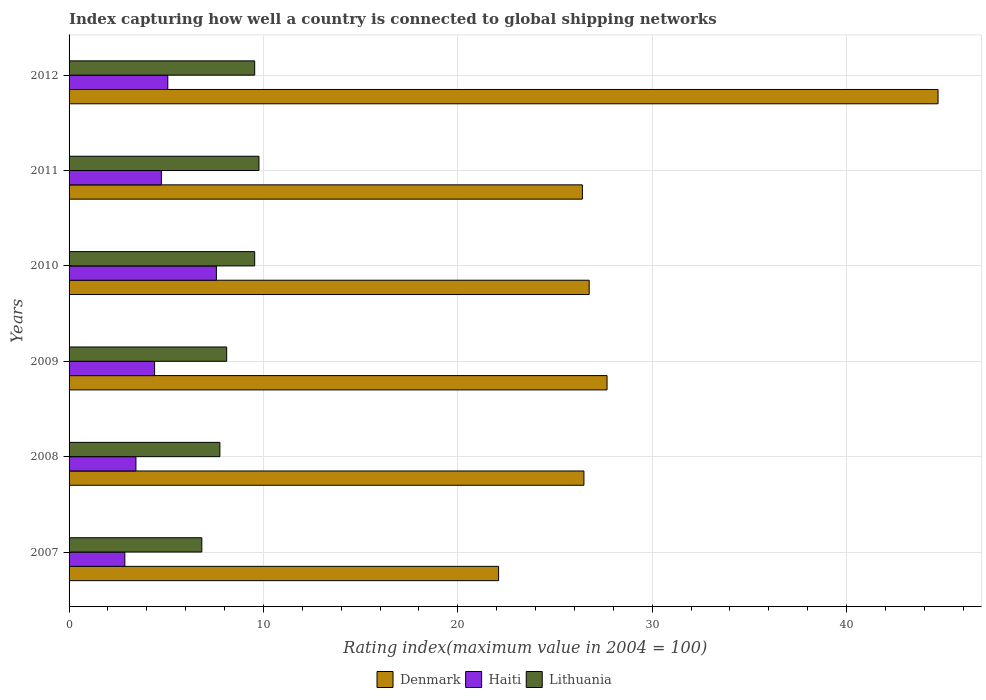How many bars are there on the 3rd tick from the top?
Provide a succinct answer. 3. How many bars are there on the 6th tick from the bottom?
Your answer should be very brief. 3. What is the label of the 6th group of bars from the top?
Your answer should be very brief. 2007. What is the rating index in Lithuania in 2007?
Your response must be concise. 6.83. Across all years, what is the maximum rating index in Haiti?
Your answer should be very brief. 7.58. Across all years, what is the minimum rating index in Lithuania?
Your answer should be very brief. 6.83. In which year was the rating index in Denmark maximum?
Ensure brevity in your answer.  2012. What is the total rating index in Denmark in the graph?
Provide a succinct answer. 174.15. What is the difference between the rating index in Lithuania in 2009 and that in 2012?
Keep it short and to the point. -1.44. What is the difference between the rating index in Haiti in 2010 and the rating index in Denmark in 2008?
Give a very brief answer. -18.91. What is the average rating index in Lithuania per year?
Your answer should be very brief. 8.59. In the year 2008, what is the difference between the rating index in Haiti and rating index in Denmark?
Give a very brief answer. -23.05. In how many years, is the rating index in Denmark greater than 38 ?
Provide a short and direct response. 1. What is the ratio of the rating index in Denmark in 2007 to that in 2009?
Your answer should be very brief. 0.8. Is the difference between the rating index in Haiti in 2009 and 2012 greater than the difference between the rating index in Denmark in 2009 and 2012?
Offer a terse response. Yes. What is the difference between the highest and the second highest rating index in Denmark?
Your answer should be compact. 17.03. What is the difference between the highest and the lowest rating index in Denmark?
Provide a succinct answer. 22.61. What does the 3rd bar from the top in 2009 represents?
Provide a short and direct response. Denmark. What does the 1st bar from the bottom in 2012 represents?
Your response must be concise. Denmark. Are all the bars in the graph horizontal?
Provide a succinct answer. Yes. Are the values on the major ticks of X-axis written in scientific E-notation?
Give a very brief answer. No. Does the graph contain any zero values?
Offer a terse response. No. Does the graph contain grids?
Provide a short and direct response. Yes. Where does the legend appear in the graph?
Your answer should be very brief. Bottom center. How are the legend labels stacked?
Your answer should be compact. Horizontal. What is the title of the graph?
Your answer should be compact. Index capturing how well a country is connected to global shipping networks. What is the label or title of the X-axis?
Keep it short and to the point. Rating index(maximum value in 2004 = 100). What is the Rating index(maximum value in 2004 = 100) in Denmark in 2007?
Your answer should be very brief. 22.1. What is the Rating index(maximum value in 2004 = 100) of Haiti in 2007?
Provide a succinct answer. 2.87. What is the Rating index(maximum value in 2004 = 100) in Lithuania in 2007?
Offer a very short reply. 6.83. What is the Rating index(maximum value in 2004 = 100) in Denmark in 2008?
Your response must be concise. 26.49. What is the Rating index(maximum value in 2004 = 100) in Haiti in 2008?
Keep it short and to the point. 3.44. What is the Rating index(maximum value in 2004 = 100) of Lithuania in 2008?
Provide a short and direct response. 7.76. What is the Rating index(maximum value in 2004 = 100) in Denmark in 2009?
Give a very brief answer. 27.68. What is the Rating index(maximum value in 2004 = 100) of Haiti in 2009?
Offer a terse response. 4.4. What is the Rating index(maximum value in 2004 = 100) of Lithuania in 2009?
Provide a short and direct response. 8.11. What is the Rating index(maximum value in 2004 = 100) of Denmark in 2010?
Your answer should be very brief. 26.76. What is the Rating index(maximum value in 2004 = 100) of Haiti in 2010?
Provide a short and direct response. 7.58. What is the Rating index(maximum value in 2004 = 100) of Lithuania in 2010?
Keep it short and to the point. 9.55. What is the Rating index(maximum value in 2004 = 100) of Denmark in 2011?
Make the answer very short. 26.41. What is the Rating index(maximum value in 2004 = 100) in Haiti in 2011?
Offer a very short reply. 4.75. What is the Rating index(maximum value in 2004 = 100) in Lithuania in 2011?
Keep it short and to the point. 9.77. What is the Rating index(maximum value in 2004 = 100) in Denmark in 2012?
Offer a very short reply. 44.71. What is the Rating index(maximum value in 2004 = 100) of Haiti in 2012?
Keep it short and to the point. 5.08. What is the Rating index(maximum value in 2004 = 100) of Lithuania in 2012?
Give a very brief answer. 9.55. Across all years, what is the maximum Rating index(maximum value in 2004 = 100) in Denmark?
Keep it short and to the point. 44.71. Across all years, what is the maximum Rating index(maximum value in 2004 = 100) of Haiti?
Make the answer very short. 7.58. Across all years, what is the maximum Rating index(maximum value in 2004 = 100) of Lithuania?
Offer a very short reply. 9.77. Across all years, what is the minimum Rating index(maximum value in 2004 = 100) of Denmark?
Give a very brief answer. 22.1. Across all years, what is the minimum Rating index(maximum value in 2004 = 100) of Haiti?
Ensure brevity in your answer.  2.87. Across all years, what is the minimum Rating index(maximum value in 2004 = 100) of Lithuania?
Keep it short and to the point. 6.83. What is the total Rating index(maximum value in 2004 = 100) in Denmark in the graph?
Make the answer very short. 174.15. What is the total Rating index(maximum value in 2004 = 100) of Haiti in the graph?
Provide a succinct answer. 28.12. What is the total Rating index(maximum value in 2004 = 100) in Lithuania in the graph?
Your answer should be compact. 51.57. What is the difference between the Rating index(maximum value in 2004 = 100) in Denmark in 2007 and that in 2008?
Your answer should be very brief. -4.39. What is the difference between the Rating index(maximum value in 2004 = 100) in Haiti in 2007 and that in 2008?
Provide a short and direct response. -0.57. What is the difference between the Rating index(maximum value in 2004 = 100) of Lithuania in 2007 and that in 2008?
Make the answer very short. -0.93. What is the difference between the Rating index(maximum value in 2004 = 100) of Denmark in 2007 and that in 2009?
Make the answer very short. -5.58. What is the difference between the Rating index(maximum value in 2004 = 100) in Haiti in 2007 and that in 2009?
Your answer should be compact. -1.53. What is the difference between the Rating index(maximum value in 2004 = 100) in Lithuania in 2007 and that in 2009?
Offer a very short reply. -1.28. What is the difference between the Rating index(maximum value in 2004 = 100) in Denmark in 2007 and that in 2010?
Provide a short and direct response. -4.66. What is the difference between the Rating index(maximum value in 2004 = 100) of Haiti in 2007 and that in 2010?
Your answer should be compact. -4.71. What is the difference between the Rating index(maximum value in 2004 = 100) in Lithuania in 2007 and that in 2010?
Offer a very short reply. -2.72. What is the difference between the Rating index(maximum value in 2004 = 100) of Denmark in 2007 and that in 2011?
Make the answer very short. -4.31. What is the difference between the Rating index(maximum value in 2004 = 100) of Haiti in 2007 and that in 2011?
Your answer should be very brief. -1.88. What is the difference between the Rating index(maximum value in 2004 = 100) of Lithuania in 2007 and that in 2011?
Your response must be concise. -2.94. What is the difference between the Rating index(maximum value in 2004 = 100) in Denmark in 2007 and that in 2012?
Offer a terse response. -22.61. What is the difference between the Rating index(maximum value in 2004 = 100) in Haiti in 2007 and that in 2012?
Provide a succinct answer. -2.21. What is the difference between the Rating index(maximum value in 2004 = 100) of Lithuania in 2007 and that in 2012?
Give a very brief answer. -2.72. What is the difference between the Rating index(maximum value in 2004 = 100) in Denmark in 2008 and that in 2009?
Ensure brevity in your answer.  -1.19. What is the difference between the Rating index(maximum value in 2004 = 100) of Haiti in 2008 and that in 2009?
Your answer should be very brief. -0.96. What is the difference between the Rating index(maximum value in 2004 = 100) in Lithuania in 2008 and that in 2009?
Your answer should be compact. -0.35. What is the difference between the Rating index(maximum value in 2004 = 100) of Denmark in 2008 and that in 2010?
Provide a succinct answer. -0.27. What is the difference between the Rating index(maximum value in 2004 = 100) in Haiti in 2008 and that in 2010?
Your answer should be very brief. -4.14. What is the difference between the Rating index(maximum value in 2004 = 100) of Lithuania in 2008 and that in 2010?
Your response must be concise. -1.79. What is the difference between the Rating index(maximum value in 2004 = 100) of Haiti in 2008 and that in 2011?
Offer a very short reply. -1.31. What is the difference between the Rating index(maximum value in 2004 = 100) of Lithuania in 2008 and that in 2011?
Offer a terse response. -2.01. What is the difference between the Rating index(maximum value in 2004 = 100) in Denmark in 2008 and that in 2012?
Your answer should be very brief. -18.22. What is the difference between the Rating index(maximum value in 2004 = 100) in Haiti in 2008 and that in 2012?
Offer a very short reply. -1.64. What is the difference between the Rating index(maximum value in 2004 = 100) of Lithuania in 2008 and that in 2012?
Give a very brief answer. -1.79. What is the difference between the Rating index(maximum value in 2004 = 100) of Haiti in 2009 and that in 2010?
Your response must be concise. -3.18. What is the difference between the Rating index(maximum value in 2004 = 100) in Lithuania in 2009 and that in 2010?
Keep it short and to the point. -1.44. What is the difference between the Rating index(maximum value in 2004 = 100) of Denmark in 2009 and that in 2011?
Provide a succinct answer. 1.27. What is the difference between the Rating index(maximum value in 2004 = 100) of Haiti in 2009 and that in 2011?
Give a very brief answer. -0.35. What is the difference between the Rating index(maximum value in 2004 = 100) of Lithuania in 2009 and that in 2011?
Keep it short and to the point. -1.66. What is the difference between the Rating index(maximum value in 2004 = 100) of Denmark in 2009 and that in 2012?
Provide a succinct answer. -17.03. What is the difference between the Rating index(maximum value in 2004 = 100) in Haiti in 2009 and that in 2012?
Your answer should be compact. -0.68. What is the difference between the Rating index(maximum value in 2004 = 100) of Lithuania in 2009 and that in 2012?
Give a very brief answer. -1.44. What is the difference between the Rating index(maximum value in 2004 = 100) in Haiti in 2010 and that in 2011?
Your answer should be very brief. 2.83. What is the difference between the Rating index(maximum value in 2004 = 100) of Lithuania in 2010 and that in 2011?
Offer a very short reply. -0.22. What is the difference between the Rating index(maximum value in 2004 = 100) in Denmark in 2010 and that in 2012?
Offer a very short reply. -17.95. What is the difference between the Rating index(maximum value in 2004 = 100) of Haiti in 2010 and that in 2012?
Offer a very short reply. 2.5. What is the difference between the Rating index(maximum value in 2004 = 100) of Denmark in 2011 and that in 2012?
Ensure brevity in your answer.  -18.3. What is the difference between the Rating index(maximum value in 2004 = 100) of Haiti in 2011 and that in 2012?
Make the answer very short. -0.33. What is the difference between the Rating index(maximum value in 2004 = 100) in Lithuania in 2011 and that in 2012?
Your answer should be compact. 0.22. What is the difference between the Rating index(maximum value in 2004 = 100) in Denmark in 2007 and the Rating index(maximum value in 2004 = 100) in Haiti in 2008?
Your response must be concise. 18.66. What is the difference between the Rating index(maximum value in 2004 = 100) of Denmark in 2007 and the Rating index(maximum value in 2004 = 100) of Lithuania in 2008?
Give a very brief answer. 14.34. What is the difference between the Rating index(maximum value in 2004 = 100) in Haiti in 2007 and the Rating index(maximum value in 2004 = 100) in Lithuania in 2008?
Keep it short and to the point. -4.89. What is the difference between the Rating index(maximum value in 2004 = 100) in Denmark in 2007 and the Rating index(maximum value in 2004 = 100) in Haiti in 2009?
Provide a succinct answer. 17.7. What is the difference between the Rating index(maximum value in 2004 = 100) of Denmark in 2007 and the Rating index(maximum value in 2004 = 100) of Lithuania in 2009?
Provide a short and direct response. 13.99. What is the difference between the Rating index(maximum value in 2004 = 100) in Haiti in 2007 and the Rating index(maximum value in 2004 = 100) in Lithuania in 2009?
Offer a very short reply. -5.24. What is the difference between the Rating index(maximum value in 2004 = 100) in Denmark in 2007 and the Rating index(maximum value in 2004 = 100) in Haiti in 2010?
Make the answer very short. 14.52. What is the difference between the Rating index(maximum value in 2004 = 100) in Denmark in 2007 and the Rating index(maximum value in 2004 = 100) in Lithuania in 2010?
Your answer should be very brief. 12.55. What is the difference between the Rating index(maximum value in 2004 = 100) of Haiti in 2007 and the Rating index(maximum value in 2004 = 100) of Lithuania in 2010?
Provide a succinct answer. -6.68. What is the difference between the Rating index(maximum value in 2004 = 100) in Denmark in 2007 and the Rating index(maximum value in 2004 = 100) in Haiti in 2011?
Your answer should be very brief. 17.35. What is the difference between the Rating index(maximum value in 2004 = 100) in Denmark in 2007 and the Rating index(maximum value in 2004 = 100) in Lithuania in 2011?
Your answer should be compact. 12.33. What is the difference between the Rating index(maximum value in 2004 = 100) of Denmark in 2007 and the Rating index(maximum value in 2004 = 100) of Haiti in 2012?
Provide a succinct answer. 17.02. What is the difference between the Rating index(maximum value in 2004 = 100) of Denmark in 2007 and the Rating index(maximum value in 2004 = 100) of Lithuania in 2012?
Offer a very short reply. 12.55. What is the difference between the Rating index(maximum value in 2004 = 100) in Haiti in 2007 and the Rating index(maximum value in 2004 = 100) in Lithuania in 2012?
Ensure brevity in your answer.  -6.68. What is the difference between the Rating index(maximum value in 2004 = 100) of Denmark in 2008 and the Rating index(maximum value in 2004 = 100) of Haiti in 2009?
Ensure brevity in your answer.  22.09. What is the difference between the Rating index(maximum value in 2004 = 100) in Denmark in 2008 and the Rating index(maximum value in 2004 = 100) in Lithuania in 2009?
Provide a succinct answer. 18.38. What is the difference between the Rating index(maximum value in 2004 = 100) in Haiti in 2008 and the Rating index(maximum value in 2004 = 100) in Lithuania in 2009?
Keep it short and to the point. -4.67. What is the difference between the Rating index(maximum value in 2004 = 100) in Denmark in 2008 and the Rating index(maximum value in 2004 = 100) in Haiti in 2010?
Your response must be concise. 18.91. What is the difference between the Rating index(maximum value in 2004 = 100) of Denmark in 2008 and the Rating index(maximum value in 2004 = 100) of Lithuania in 2010?
Ensure brevity in your answer.  16.94. What is the difference between the Rating index(maximum value in 2004 = 100) of Haiti in 2008 and the Rating index(maximum value in 2004 = 100) of Lithuania in 2010?
Give a very brief answer. -6.11. What is the difference between the Rating index(maximum value in 2004 = 100) of Denmark in 2008 and the Rating index(maximum value in 2004 = 100) of Haiti in 2011?
Give a very brief answer. 21.74. What is the difference between the Rating index(maximum value in 2004 = 100) of Denmark in 2008 and the Rating index(maximum value in 2004 = 100) of Lithuania in 2011?
Keep it short and to the point. 16.72. What is the difference between the Rating index(maximum value in 2004 = 100) in Haiti in 2008 and the Rating index(maximum value in 2004 = 100) in Lithuania in 2011?
Ensure brevity in your answer.  -6.33. What is the difference between the Rating index(maximum value in 2004 = 100) of Denmark in 2008 and the Rating index(maximum value in 2004 = 100) of Haiti in 2012?
Provide a succinct answer. 21.41. What is the difference between the Rating index(maximum value in 2004 = 100) of Denmark in 2008 and the Rating index(maximum value in 2004 = 100) of Lithuania in 2012?
Ensure brevity in your answer.  16.94. What is the difference between the Rating index(maximum value in 2004 = 100) in Haiti in 2008 and the Rating index(maximum value in 2004 = 100) in Lithuania in 2012?
Offer a very short reply. -6.11. What is the difference between the Rating index(maximum value in 2004 = 100) of Denmark in 2009 and the Rating index(maximum value in 2004 = 100) of Haiti in 2010?
Offer a terse response. 20.1. What is the difference between the Rating index(maximum value in 2004 = 100) of Denmark in 2009 and the Rating index(maximum value in 2004 = 100) of Lithuania in 2010?
Your response must be concise. 18.13. What is the difference between the Rating index(maximum value in 2004 = 100) in Haiti in 2009 and the Rating index(maximum value in 2004 = 100) in Lithuania in 2010?
Your answer should be very brief. -5.15. What is the difference between the Rating index(maximum value in 2004 = 100) in Denmark in 2009 and the Rating index(maximum value in 2004 = 100) in Haiti in 2011?
Your answer should be very brief. 22.93. What is the difference between the Rating index(maximum value in 2004 = 100) of Denmark in 2009 and the Rating index(maximum value in 2004 = 100) of Lithuania in 2011?
Your response must be concise. 17.91. What is the difference between the Rating index(maximum value in 2004 = 100) of Haiti in 2009 and the Rating index(maximum value in 2004 = 100) of Lithuania in 2011?
Give a very brief answer. -5.37. What is the difference between the Rating index(maximum value in 2004 = 100) of Denmark in 2009 and the Rating index(maximum value in 2004 = 100) of Haiti in 2012?
Keep it short and to the point. 22.6. What is the difference between the Rating index(maximum value in 2004 = 100) in Denmark in 2009 and the Rating index(maximum value in 2004 = 100) in Lithuania in 2012?
Provide a short and direct response. 18.13. What is the difference between the Rating index(maximum value in 2004 = 100) in Haiti in 2009 and the Rating index(maximum value in 2004 = 100) in Lithuania in 2012?
Your response must be concise. -5.15. What is the difference between the Rating index(maximum value in 2004 = 100) of Denmark in 2010 and the Rating index(maximum value in 2004 = 100) of Haiti in 2011?
Make the answer very short. 22.01. What is the difference between the Rating index(maximum value in 2004 = 100) of Denmark in 2010 and the Rating index(maximum value in 2004 = 100) of Lithuania in 2011?
Your response must be concise. 16.99. What is the difference between the Rating index(maximum value in 2004 = 100) in Haiti in 2010 and the Rating index(maximum value in 2004 = 100) in Lithuania in 2011?
Provide a short and direct response. -2.19. What is the difference between the Rating index(maximum value in 2004 = 100) of Denmark in 2010 and the Rating index(maximum value in 2004 = 100) of Haiti in 2012?
Offer a terse response. 21.68. What is the difference between the Rating index(maximum value in 2004 = 100) of Denmark in 2010 and the Rating index(maximum value in 2004 = 100) of Lithuania in 2012?
Offer a terse response. 17.21. What is the difference between the Rating index(maximum value in 2004 = 100) in Haiti in 2010 and the Rating index(maximum value in 2004 = 100) in Lithuania in 2012?
Your answer should be very brief. -1.97. What is the difference between the Rating index(maximum value in 2004 = 100) of Denmark in 2011 and the Rating index(maximum value in 2004 = 100) of Haiti in 2012?
Make the answer very short. 21.33. What is the difference between the Rating index(maximum value in 2004 = 100) of Denmark in 2011 and the Rating index(maximum value in 2004 = 100) of Lithuania in 2012?
Provide a succinct answer. 16.86. What is the average Rating index(maximum value in 2004 = 100) of Denmark per year?
Your answer should be very brief. 29.02. What is the average Rating index(maximum value in 2004 = 100) in Haiti per year?
Provide a short and direct response. 4.69. What is the average Rating index(maximum value in 2004 = 100) of Lithuania per year?
Offer a terse response. 8.6. In the year 2007, what is the difference between the Rating index(maximum value in 2004 = 100) in Denmark and Rating index(maximum value in 2004 = 100) in Haiti?
Offer a very short reply. 19.23. In the year 2007, what is the difference between the Rating index(maximum value in 2004 = 100) in Denmark and Rating index(maximum value in 2004 = 100) in Lithuania?
Provide a short and direct response. 15.27. In the year 2007, what is the difference between the Rating index(maximum value in 2004 = 100) in Haiti and Rating index(maximum value in 2004 = 100) in Lithuania?
Offer a very short reply. -3.96. In the year 2008, what is the difference between the Rating index(maximum value in 2004 = 100) in Denmark and Rating index(maximum value in 2004 = 100) in Haiti?
Offer a very short reply. 23.05. In the year 2008, what is the difference between the Rating index(maximum value in 2004 = 100) of Denmark and Rating index(maximum value in 2004 = 100) of Lithuania?
Your answer should be very brief. 18.73. In the year 2008, what is the difference between the Rating index(maximum value in 2004 = 100) of Haiti and Rating index(maximum value in 2004 = 100) of Lithuania?
Give a very brief answer. -4.32. In the year 2009, what is the difference between the Rating index(maximum value in 2004 = 100) of Denmark and Rating index(maximum value in 2004 = 100) of Haiti?
Your answer should be compact. 23.28. In the year 2009, what is the difference between the Rating index(maximum value in 2004 = 100) in Denmark and Rating index(maximum value in 2004 = 100) in Lithuania?
Your response must be concise. 19.57. In the year 2009, what is the difference between the Rating index(maximum value in 2004 = 100) in Haiti and Rating index(maximum value in 2004 = 100) in Lithuania?
Provide a succinct answer. -3.71. In the year 2010, what is the difference between the Rating index(maximum value in 2004 = 100) in Denmark and Rating index(maximum value in 2004 = 100) in Haiti?
Your answer should be very brief. 19.18. In the year 2010, what is the difference between the Rating index(maximum value in 2004 = 100) of Denmark and Rating index(maximum value in 2004 = 100) of Lithuania?
Keep it short and to the point. 17.21. In the year 2010, what is the difference between the Rating index(maximum value in 2004 = 100) in Haiti and Rating index(maximum value in 2004 = 100) in Lithuania?
Provide a short and direct response. -1.97. In the year 2011, what is the difference between the Rating index(maximum value in 2004 = 100) of Denmark and Rating index(maximum value in 2004 = 100) of Haiti?
Your answer should be compact. 21.66. In the year 2011, what is the difference between the Rating index(maximum value in 2004 = 100) in Denmark and Rating index(maximum value in 2004 = 100) in Lithuania?
Your response must be concise. 16.64. In the year 2011, what is the difference between the Rating index(maximum value in 2004 = 100) of Haiti and Rating index(maximum value in 2004 = 100) of Lithuania?
Your answer should be very brief. -5.02. In the year 2012, what is the difference between the Rating index(maximum value in 2004 = 100) in Denmark and Rating index(maximum value in 2004 = 100) in Haiti?
Offer a very short reply. 39.63. In the year 2012, what is the difference between the Rating index(maximum value in 2004 = 100) in Denmark and Rating index(maximum value in 2004 = 100) in Lithuania?
Ensure brevity in your answer.  35.16. In the year 2012, what is the difference between the Rating index(maximum value in 2004 = 100) of Haiti and Rating index(maximum value in 2004 = 100) of Lithuania?
Your answer should be very brief. -4.47. What is the ratio of the Rating index(maximum value in 2004 = 100) of Denmark in 2007 to that in 2008?
Your answer should be compact. 0.83. What is the ratio of the Rating index(maximum value in 2004 = 100) in Haiti in 2007 to that in 2008?
Make the answer very short. 0.83. What is the ratio of the Rating index(maximum value in 2004 = 100) in Lithuania in 2007 to that in 2008?
Your answer should be compact. 0.88. What is the ratio of the Rating index(maximum value in 2004 = 100) in Denmark in 2007 to that in 2009?
Give a very brief answer. 0.8. What is the ratio of the Rating index(maximum value in 2004 = 100) in Haiti in 2007 to that in 2009?
Your answer should be very brief. 0.65. What is the ratio of the Rating index(maximum value in 2004 = 100) of Lithuania in 2007 to that in 2009?
Make the answer very short. 0.84. What is the ratio of the Rating index(maximum value in 2004 = 100) in Denmark in 2007 to that in 2010?
Your answer should be compact. 0.83. What is the ratio of the Rating index(maximum value in 2004 = 100) of Haiti in 2007 to that in 2010?
Give a very brief answer. 0.38. What is the ratio of the Rating index(maximum value in 2004 = 100) in Lithuania in 2007 to that in 2010?
Provide a short and direct response. 0.72. What is the ratio of the Rating index(maximum value in 2004 = 100) in Denmark in 2007 to that in 2011?
Make the answer very short. 0.84. What is the ratio of the Rating index(maximum value in 2004 = 100) of Haiti in 2007 to that in 2011?
Provide a succinct answer. 0.6. What is the ratio of the Rating index(maximum value in 2004 = 100) of Lithuania in 2007 to that in 2011?
Provide a short and direct response. 0.7. What is the ratio of the Rating index(maximum value in 2004 = 100) of Denmark in 2007 to that in 2012?
Your answer should be very brief. 0.49. What is the ratio of the Rating index(maximum value in 2004 = 100) of Haiti in 2007 to that in 2012?
Ensure brevity in your answer.  0.56. What is the ratio of the Rating index(maximum value in 2004 = 100) of Lithuania in 2007 to that in 2012?
Give a very brief answer. 0.72. What is the ratio of the Rating index(maximum value in 2004 = 100) in Denmark in 2008 to that in 2009?
Make the answer very short. 0.96. What is the ratio of the Rating index(maximum value in 2004 = 100) in Haiti in 2008 to that in 2009?
Your response must be concise. 0.78. What is the ratio of the Rating index(maximum value in 2004 = 100) of Lithuania in 2008 to that in 2009?
Offer a terse response. 0.96. What is the ratio of the Rating index(maximum value in 2004 = 100) in Haiti in 2008 to that in 2010?
Provide a short and direct response. 0.45. What is the ratio of the Rating index(maximum value in 2004 = 100) of Lithuania in 2008 to that in 2010?
Provide a short and direct response. 0.81. What is the ratio of the Rating index(maximum value in 2004 = 100) of Denmark in 2008 to that in 2011?
Your response must be concise. 1. What is the ratio of the Rating index(maximum value in 2004 = 100) of Haiti in 2008 to that in 2011?
Provide a succinct answer. 0.72. What is the ratio of the Rating index(maximum value in 2004 = 100) in Lithuania in 2008 to that in 2011?
Offer a terse response. 0.79. What is the ratio of the Rating index(maximum value in 2004 = 100) in Denmark in 2008 to that in 2012?
Keep it short and to the point. 0.59. What is the ratio of the Rating index(maximum value in 2004 = 100) of Haiti in 2008 to that in 2012?
Make the answer very short. 0.68. What is the ratio of the Rating index(maximum value in 2004 = 100) in Lithuania in 2008 to that in 2012?
Offer a terse response. 0.81. What is the ratio of the Rating index(maximum value in 2004 = 100) of Denmark in 2009 to that in 2010?
Your answer should be very brief. 1.03. What is the ratio of the Rating index(maximum value in 2004 = 100) of Haiti in 2009 to that in 2010?
Provide a succinct answer. 0.58. What is the ratio of the Rating index(maximum value in 2004 = 100) in Lithuania in 2009 to that in 2010?
Keep it short and to the point. 0.85. What is the ratio of the Rating index(maximum value in 2004 = 100) of Denmark in 2009 to that in 2011?
Offer a terse response. 1.05. What is the ratio of the Rating index(maximum value in 2004 = 100) of Haiti in 2009 to that in 2011?
Ensure brevity in your answer.  0.93. What is the ratio of the Rating index(maximum value in 2004 = 100) of Lithuania in 2009 to that in 2011?
Give a very brief answer. 0.83. What is the ratio of the Rating index(maximum value in 2004 = 100) in Denmark in 2009 to that in 2012?
Offer a very short reply. 0.62. What is the ratio of the Rating index(maximum value in 2004 = 100) in Haiti in 2009 to that in 2012?
Ensure brevity in your answer.  0.87. What is the ratio of the Rating index(maximum value in 2004 = 100) in Lithuania in 2009 to that in 2012?
Provide a succinct answer. 0.85. What is the ratio of the Rating index(maximum value in 2004 = 100) in Denmark in 2010 to that in 2011?
Your answer should be compact. 1.01. What is the ratio of the Rating index(maximum value in 2004 = 100) of Haiti in 2010 to that in 2011?
Provide a short and direct response. 1.6. What is the ratio of the Rating index(maximum value in 2004 = 100) in Lithuania in 2010 to that in 2011?
Give a very brief answer. 0.98. What is the ratio of the Rating index(maximum value in 2004 = 100) of Denmark in 2010 to that in 2012?
Give a very brief answer. 0.6. What is the ratio of the Rating index(maximum value in 2004 = 100) in Haiti in 2010 to that in 2012?
Provide a succinct answer. 1.49. What is the ratio of the Rating index(maximum value in 2004 = 100) in Lithuania in 2010 to that in 2012?
Provide a succinct answer. 1. What is the ratio of the Rating index(maximum value in 2004 = 100) of Denmark in 2011 to that in 2012?
Your answer should be very brief. 0.59. What is the ratio of the Rating index(maximum value in 2004 = 100) in Haiti in 2011 to that in 2012?
Provide a short and direct response. 0.94. What is the difference between the highest and the second highest Rating index(maximum value in 2004 = 100) of Denmark?
Your response must be concise. 17.03. What is the difference between the highest and the second highest Rating index(maximum value in 2004 = 100) in Haiti?
Offer a very short reply. 2.5. What is the difference between the highest and the second highest Rating index(maximum value in 2004 = 100) in Lithuania?
Ensure brevity in your answer.  0.22. What is the difference between the highest and the lowest Rating index(maximum value in 2004 = 100) of Denmark?
Make the answer very short. 22.61. What is the difference between the highest and the lowest Rating index(maximum value in 2004 = 100) in Haiti?
Provide a short and direct response. 4.71. What is the difference between the highest and the lowest Rating index(maximum value in 2004 = 100) of Lithuania?
Your answer should be compact. 2.94. 